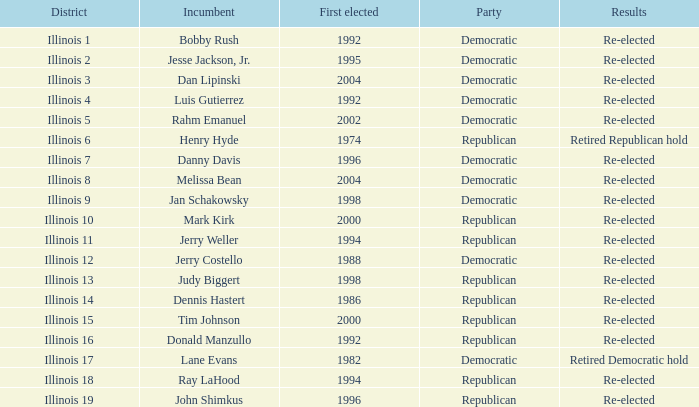What is the First Elected date of the Republican with Results of retired republican hold? 1974.0. 